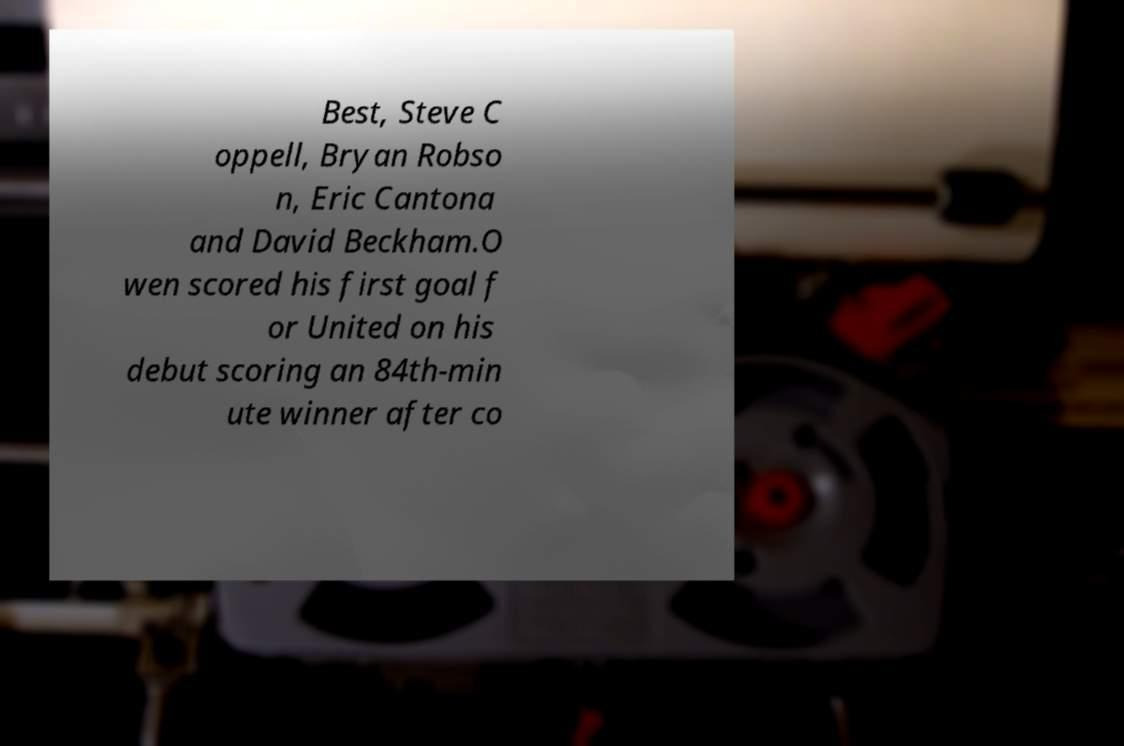Can you accurately transcribe the text from the provided image for me? Best, Steve C oppell, Bryan Robso n, Eric Cantona and David Beckham.O wen scored his first goal f or United on his debut scoring an 84th-min ute winner after co 